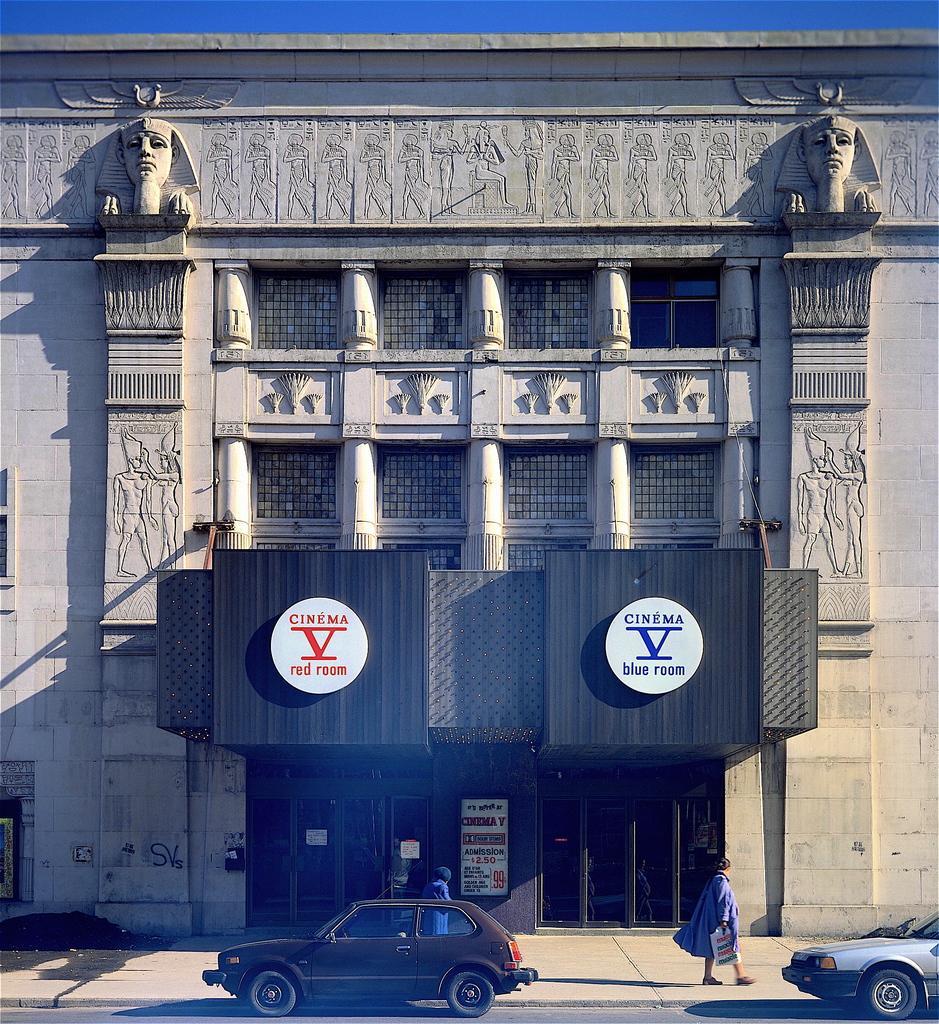Please provide a concise description of this image. In this picture there is a building which has few sculptures on the walls of the building and there are two persons and vehicles in front of it. 